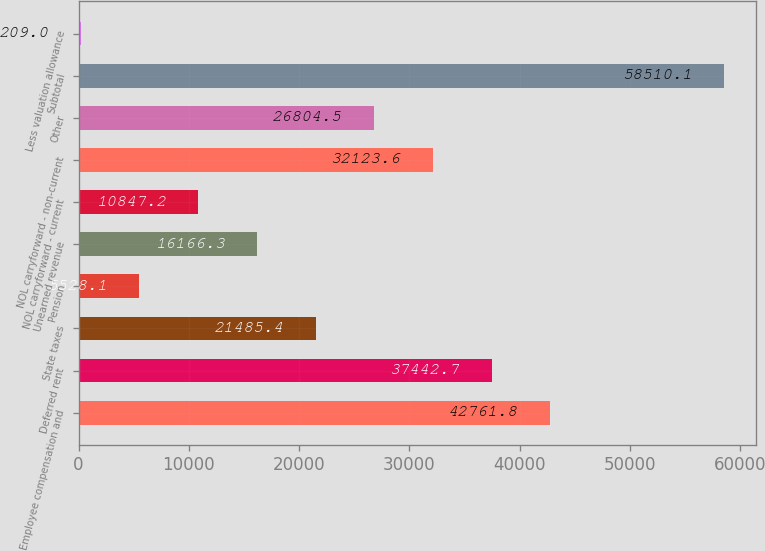<chart> <loc_0><loc_0><loc_500><loc_500><bar_chart><fcel>Employee compensation and<fcel>Deferred rent<fcel>State taxes<fcel>Pension<fcel>Unearned revenue<fcel>NOL carryforward - current<fcel>NOL carryforward - non-current<fcel>Other<fcel>Subtotal<fcel>Less valuation allowance<nl><fcel>42761.8<fcel>37442.7<fcel>21485.4<fcel>5528.1<fcel>16166.3<fcel>10847.2<fcel>32123.6<fcel>26804.5<fcel>58510.1<fcel>209<nl></chart> 